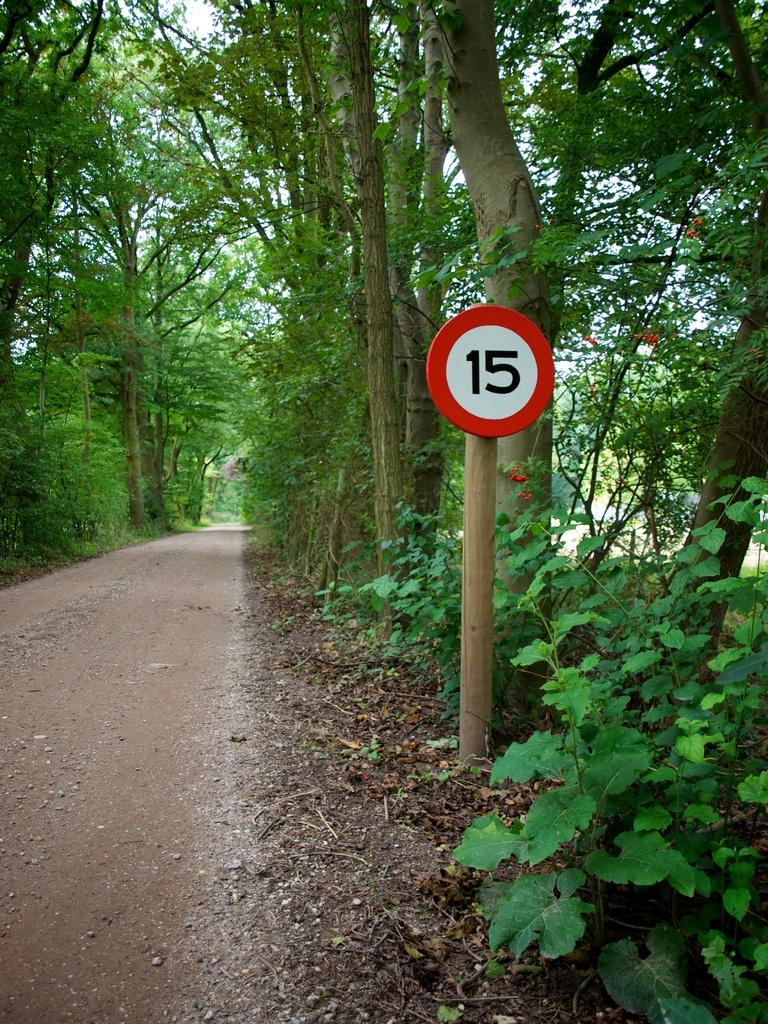<image>
Provide a brief description of the given image. A sign with the number 15 on it on a roadside in the forest. 